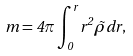Convert formula to latex. <formula><loc_0><loc_0><loc_500><loc_500>m = 4 \pi \int ^ { r } _ { 0 } { r ^ { 2 } \tilde { \rho } d r } , \\</formula> 